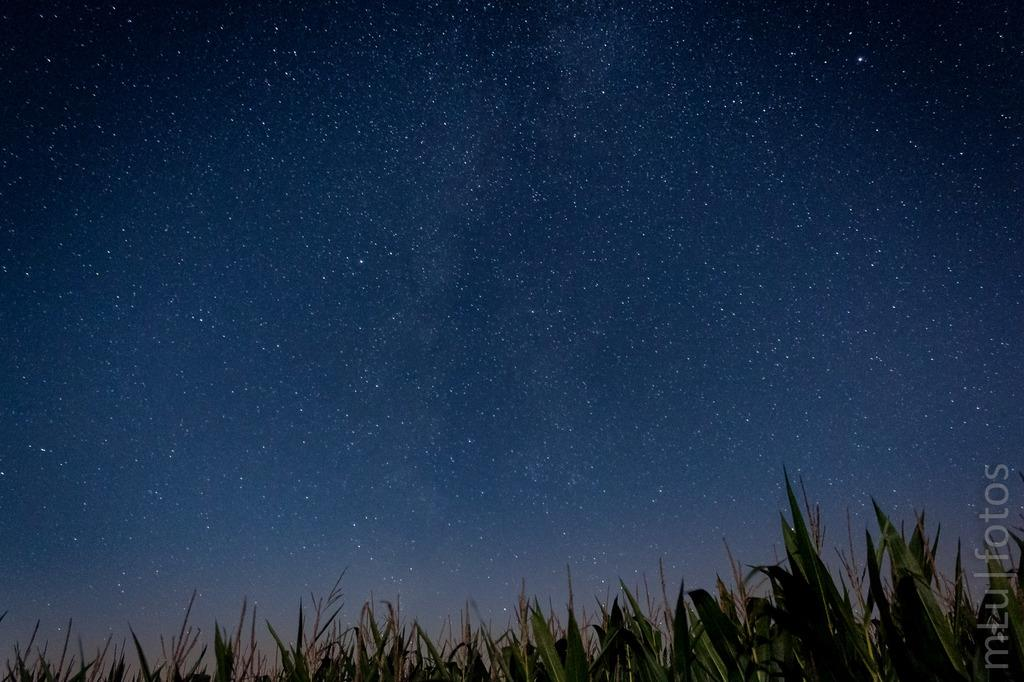What is located in the middle of the image? There are plants in the middle of the image. What can be seen in the background of the image? The sky is visible in the background of the image. Is there any text or logo present in the image? Yes, there is a watermark in the bottom right corner of the image. Can you see a baseball game happening in the image? No, there is no baseball game or any reference to sports in the image. 